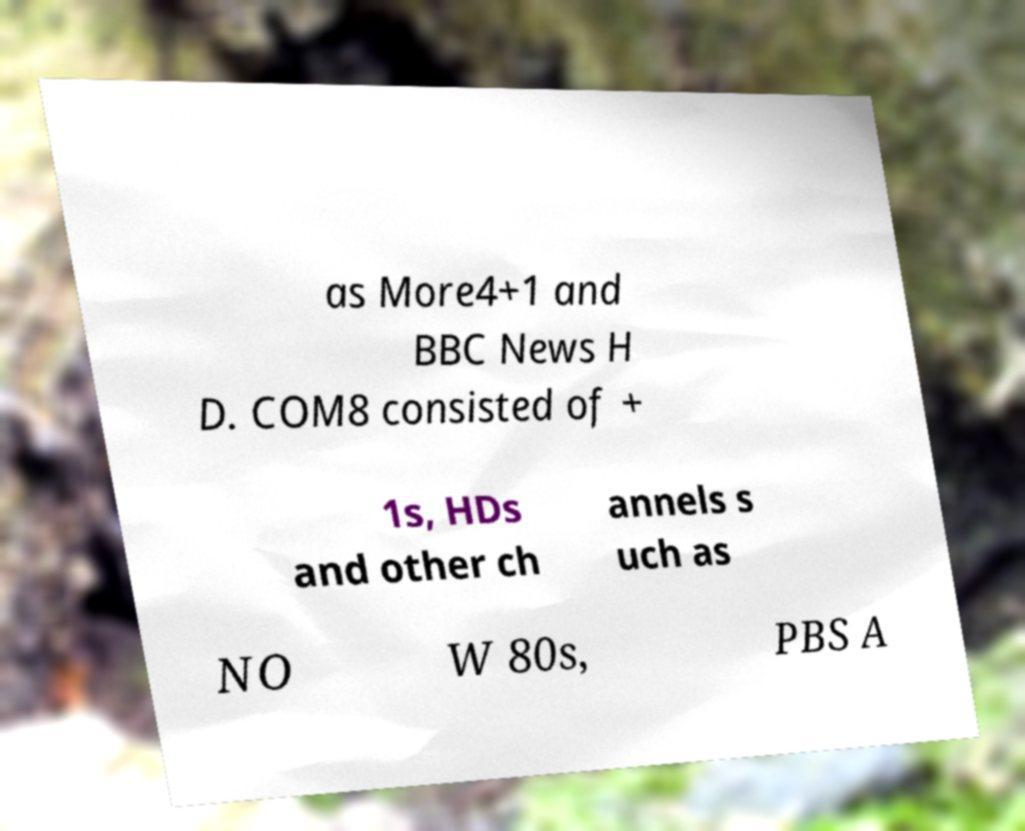There's text embedded in this image that I need extracted. Can you transcribe it verbatim? as More4+1 and BBC News H D. COM8 consisted of + 1s, HDs and other ch annels s uch as NO W 80s, PBS A 